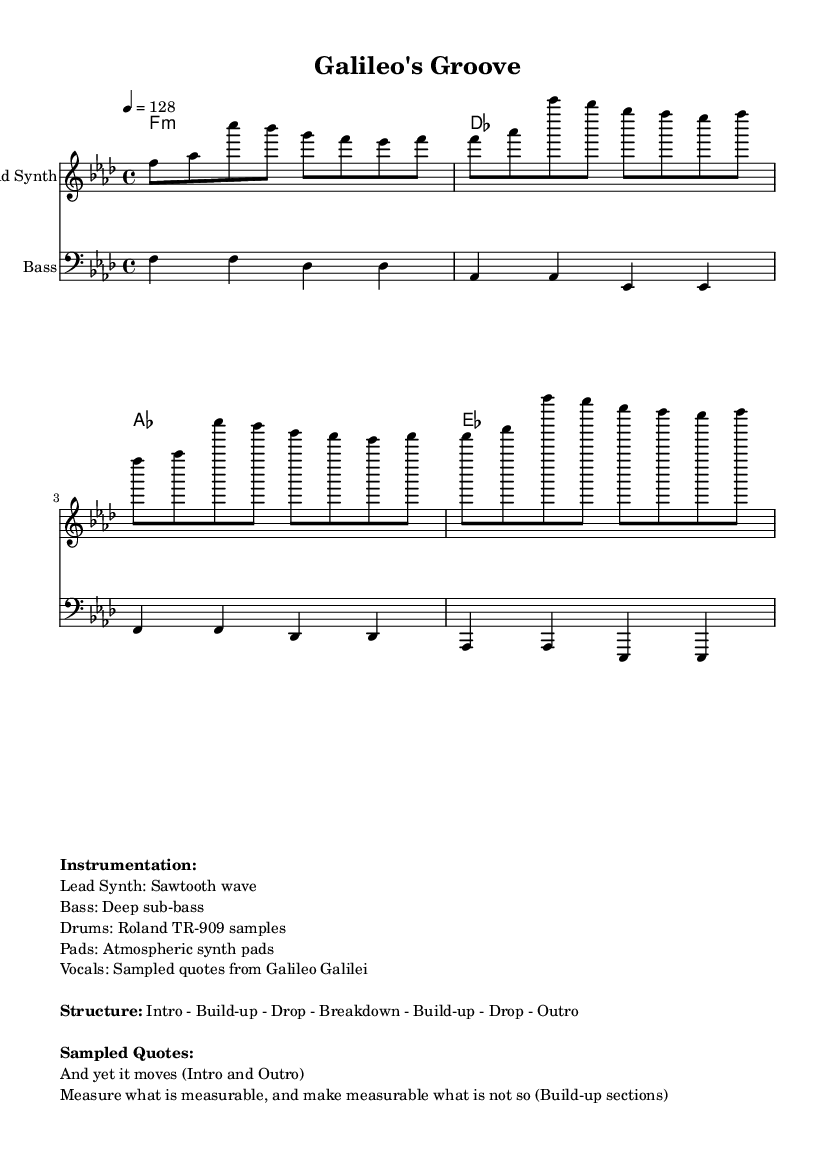What is the key signature of this music? The key signature indicated in the music sheet is F minor, which contains four flats. Therefore, we look for the key signature at the beginning of the staff, which shows these flats.
Answer: F minor What is the time signature of this music? The time signature is found at the beginning of the music sheet. It is represented by the '4/4' notation, indicating four beats per measure, with a quarter note getting one beat.
Answer: 4/4 What is the tempo marking for this piece? The tempo marking is given in the form of beats per minute at the beginning of the piece. Here, it shows '4 = 128,' indicating the tempo is set to 128 beats per minute.
Answer: 128 How many sampled quotes are listed in the markup? The markup section specifies that there are two sampled quotes from Galileo Galilei used within the track. By counting the items presented under 'Sampled Quotes,' we see there are two distinct quotes.
Answer: 2 What is the structure of the track? The structure is detailed in the markup with the various sections defined. It lists: Intro, Build-up, Drop, Breakdown, Build-up, Drop, and Outro, providing a clear layout of the track's structure.
Answer: Intro - Build-up - Drop - Breakdown - Build-up - Drop - Outro What instrument is used for the lead synth part? The instrumentation section specifies that the lead synth uses a sawtooth wave, which is commonly employed in house music for its bright and rich sound. This detail can be found under 'Instrumentation’ in the markup.
Answer: Sawtooth wave What type of bass is indicated in this piece? The bass is described in the markup where it states that a deep sub-bass is used. This type of bass is a characteristic sound in house music, giving it a strong foundation.
Answer: Deep sub-bass 